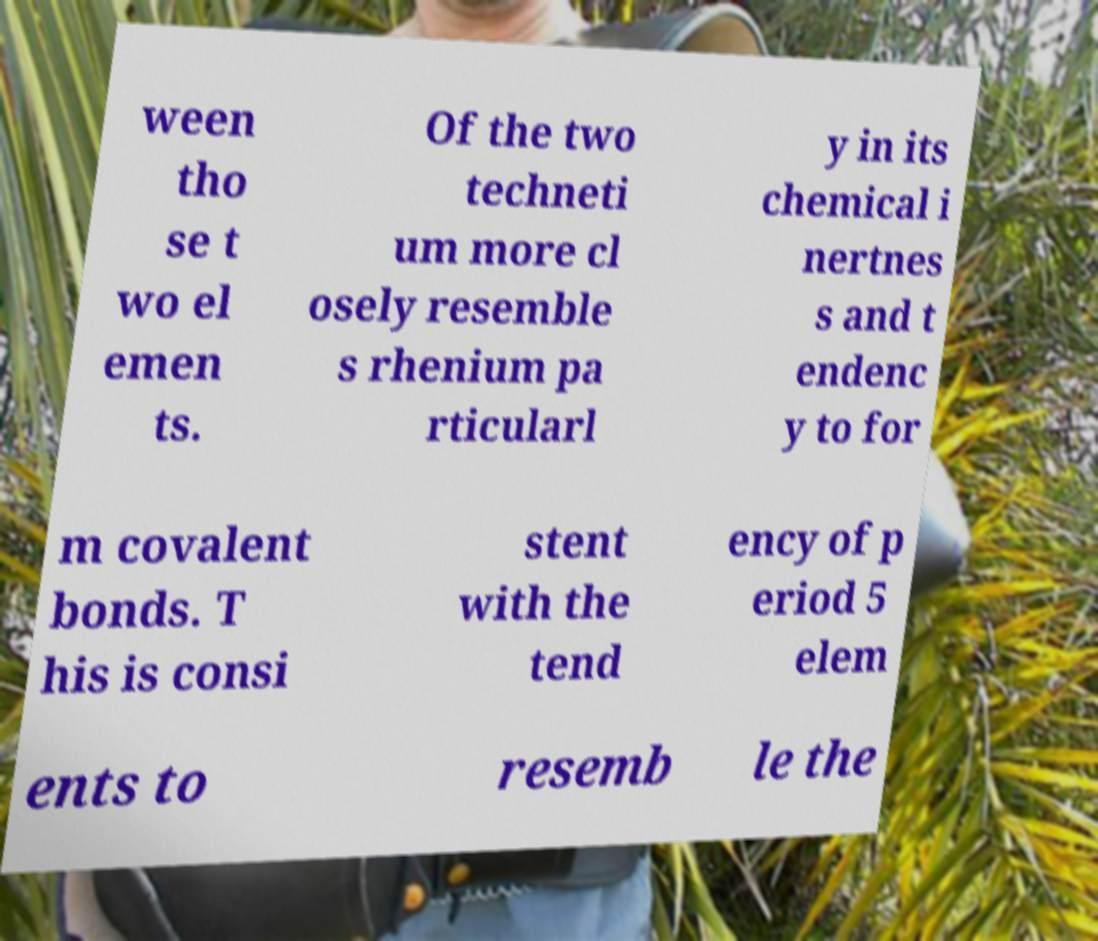Can you accurately transcribe the text from the provided image for me? ween tho se t wo el emen ts. Of the two techneti um more cl osely resemble s rhenium pa rticularl y in its chemical i nertnes s and t endenc y to for m covalent bonds. T his is consi stent with the tend ency of p eriod 5 elem ents to resemb le the 